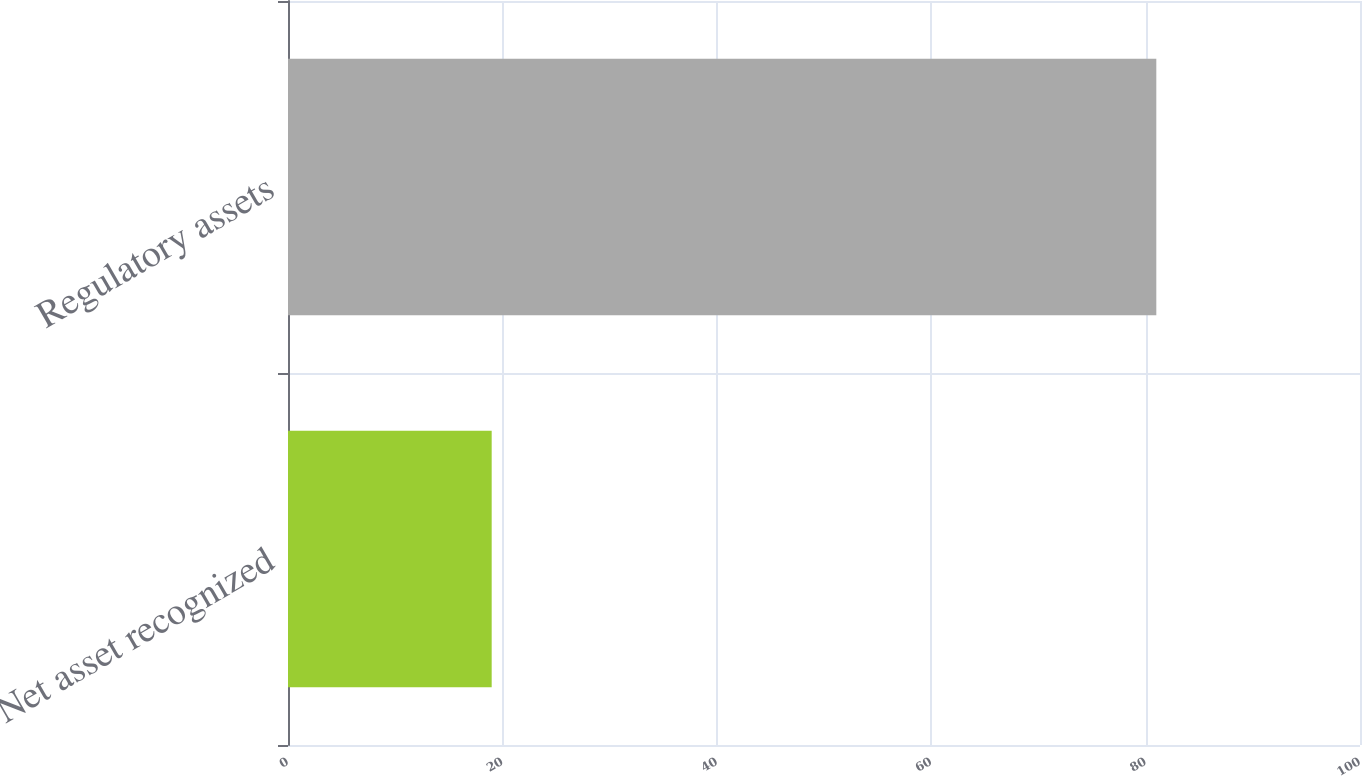Convert chart. <chart><loc_0><loc_0><loc_500><loc_500><bar_chart><fcel>Net asset recognized<fcel>Regulatory assets<nl><fcel>19<fcel>81<nl></chart> 